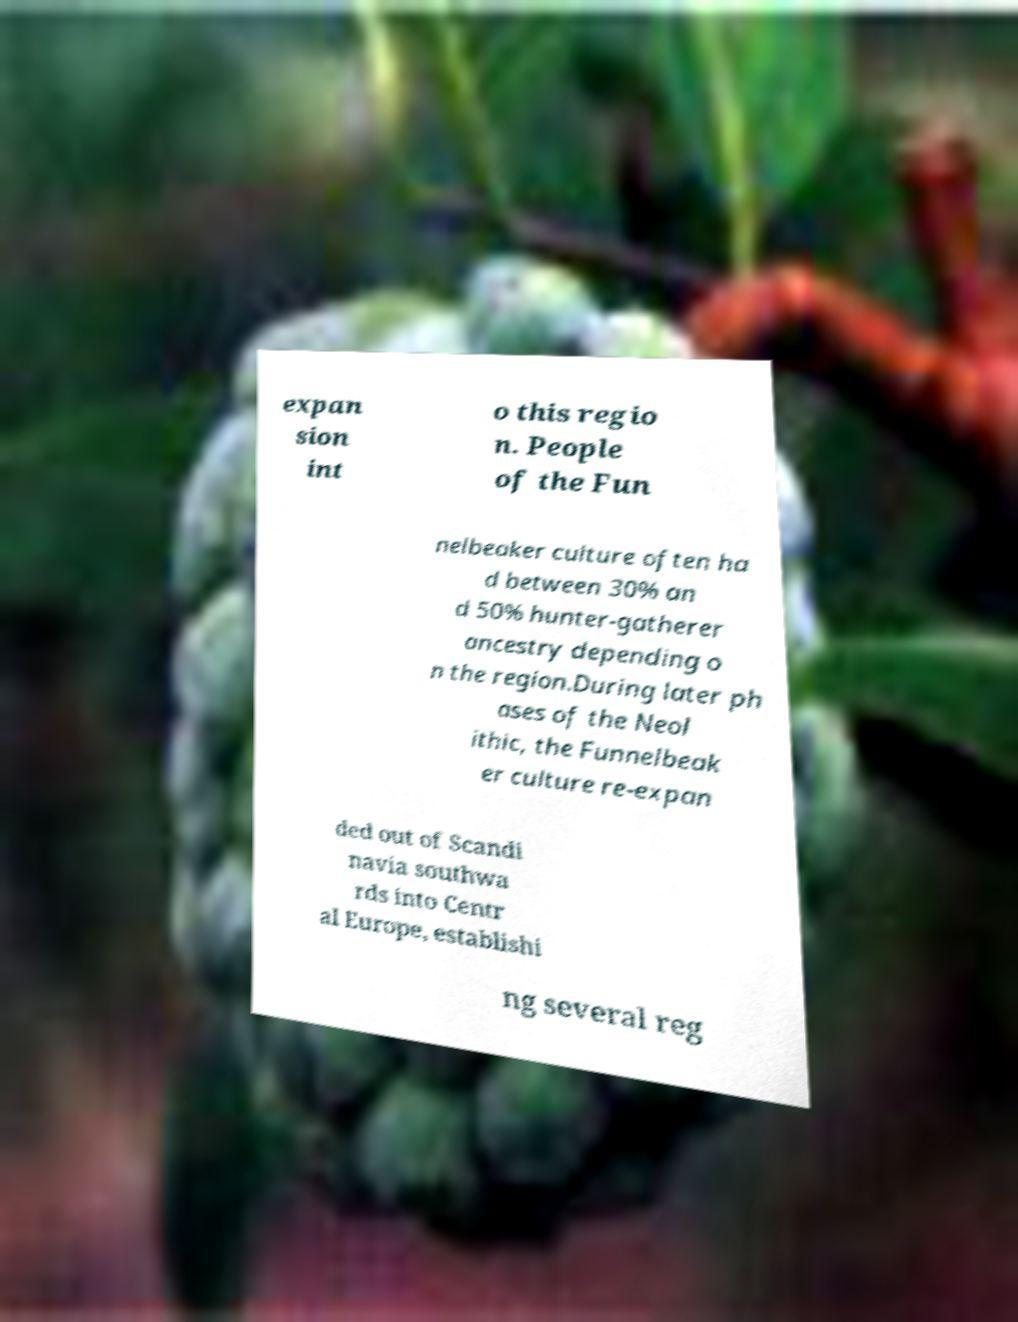For documentation purposes, I need the text within this image transcribed. Could you provide that? expan sion int o this regio n. People of the Fun nelbeaker culture often ha d between 30% an d 50% hunter-gatherer ancestry depending o n the region.During later ph ases of the Neol ithic, the Funnelbeak er culture re-expan ded out of Scandi navia southwa rds into Centr al Europe, establishi ng several reg 